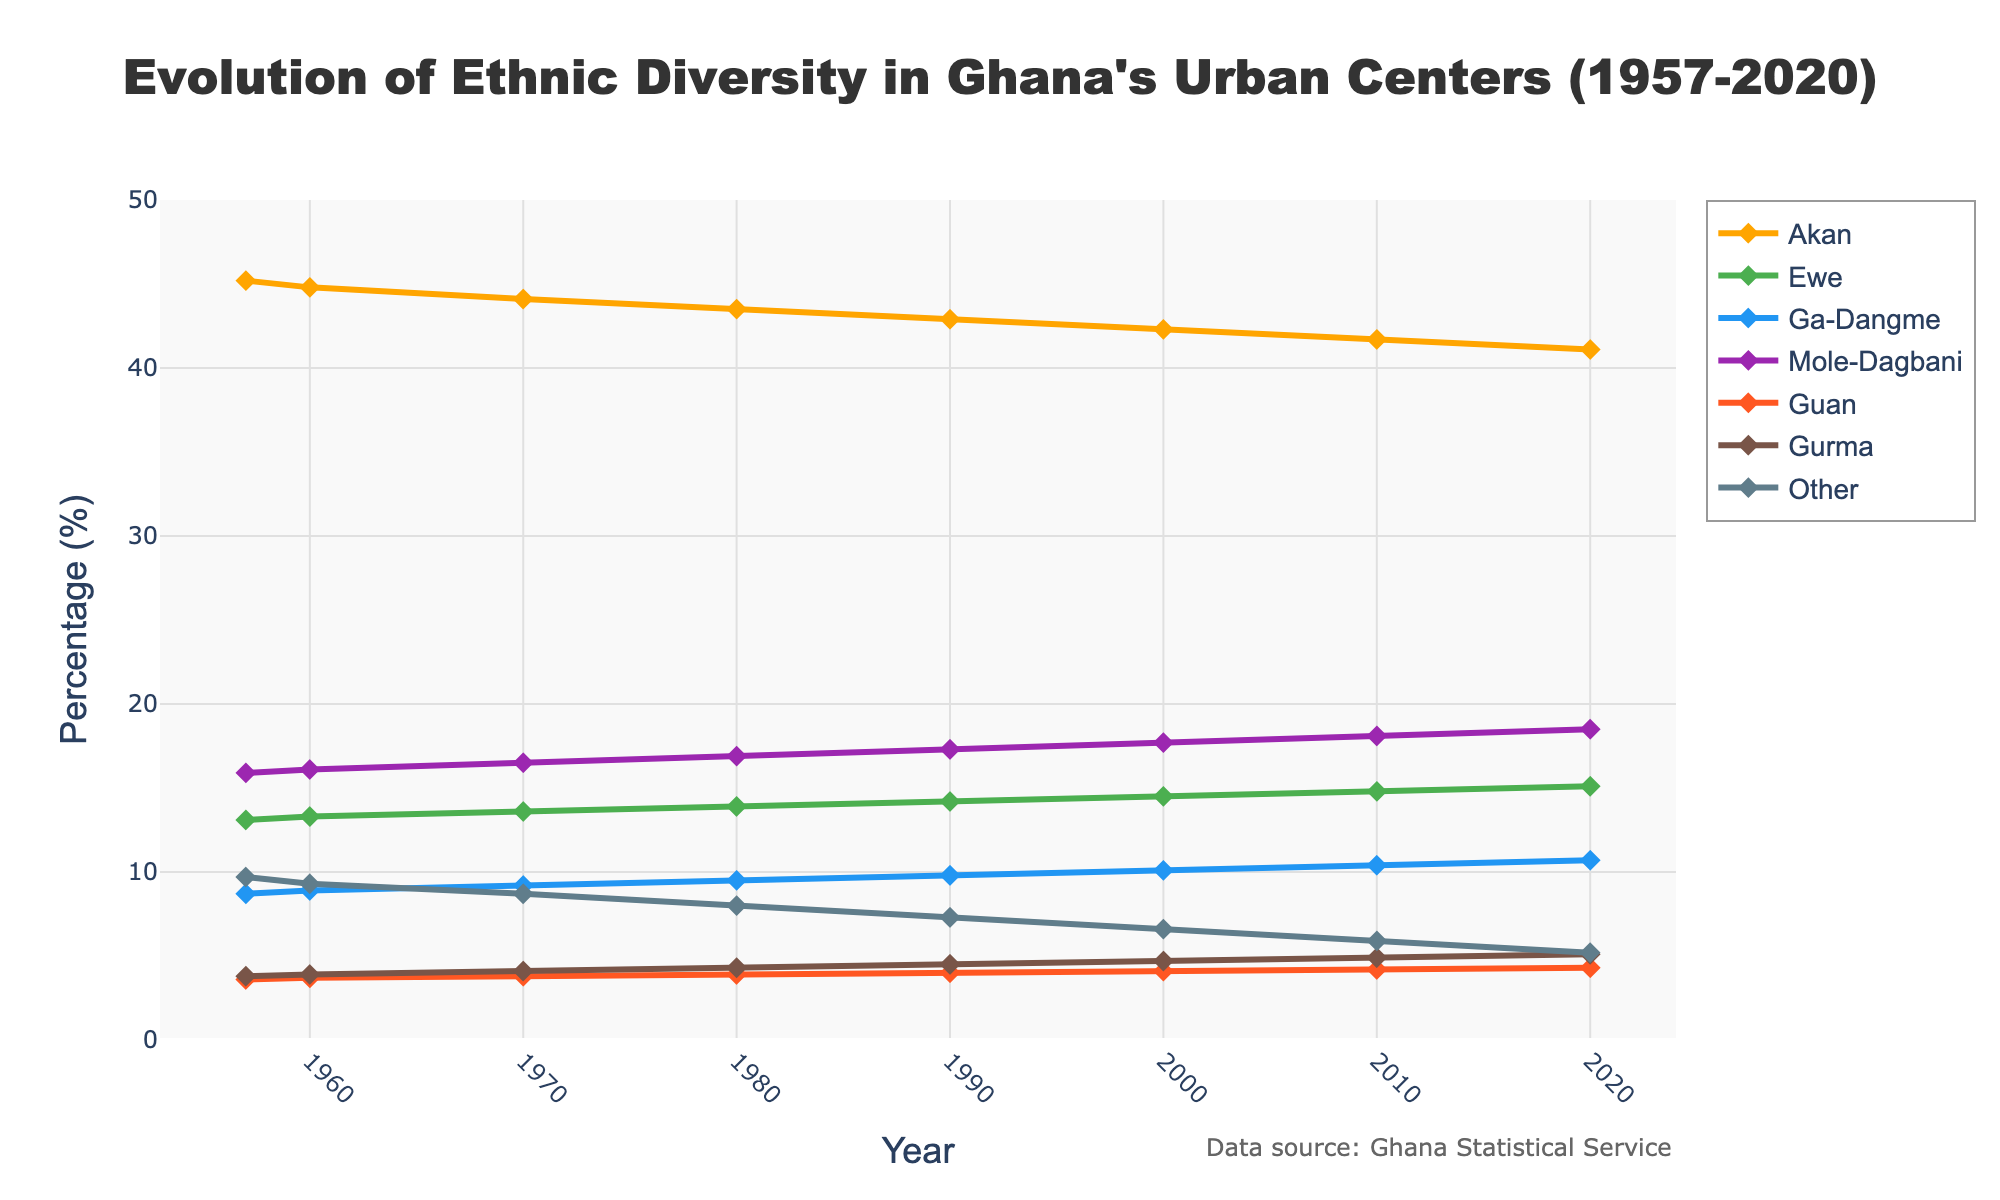What was the percentage of the Akan ethnic group in 1957 compared to 2020? The percentage of the Akan ethnic group in 1957 was 45.2%, and in 2020, it was 41.1%. Thus, the percentage of the Akan ethnic group decreased by 45.2% - 41.1% = 4.1% over the given period.
Answer: 4.1% Which ethnic group showed the most significant increase in percentage from 1957 to 2020? By comparing the percentages for each ethnic group in 1957 and 2020, Mole-Dagbani increased from 15.9% to 18.5%, a rise of 2.6%. Ewe increased from 13.1% to 15.1%, a rise of 2%. The other ethnic groups show minor increases or decreases, making Mole-Dagbani the group with the most significant increase.
Answer: Mole-Dagbani In which year did the Ga-Dangme ethnic group's percentage surpass 10%? By examining the plot, the percentage for Ga-Dangme was 8.7% in 1957 and gradually increased to 10.4% by 2010. Thus, the first year it surpassed 10% is 2000.
Answer: 2000 Which year shows the highest percentage for the Mole-Dagbani ethnic group? From the plot, the percentage of the Mole-Dagbani ethnic group gradually increases from 15.9% in 1957 to 18.5% in 2020. The highest percentage shown is 18.5% in 2020.
Answer: 2020 What is the combined percentage of the Ewe and Guan ethnic groups in 1970? From the plot, the percentage for the Ewe ethnic group in 1970 is 13.6%, and for the Guan ethnic group, it is 3.8%. Thus, the combined percentage is 13.6% + 3.8% = 17.4%.
Answer: 17.4% Did the percentage of the Gurma ethnic group ever become constant over time? The plot shows a gradual increase in the percentage of the Gurma ethnic group from 3.8% in 1957 to 5.1% in 2020. There are no periods of constancy; hence, the percentage never stayed constant over time.
Answer: No How does the percentage of the 'Other' ethnic groups trend over time between 1957 and 2020? From the plot, the percentage of the 'Other' ethnic groups decreases from 9.7% in 1957 to 5.2% in 2020, indicating a decreasing trend over time.
Answer: Decreasing What is the difference in the percentages of the Mole-Dagbani and Akan ethnic groups in 2020? The percentage of the Mole-Dagbani ethnic group in 2020 is 18.5%, and the Akan ethnic group is 41.1%. The difference is 41.1% - 18.5% = 22.6%.
Answer: 22.6% Which ethnic group had the second highest percentage in 1960? By examining the plot, the Akan ethnic group had the highest percentage in 1960 at 44.8%, and the Mole-Dagbani ethnic group had the second highest percentage at 16.1%.
Answer: Mole-Dagbani How much did the percentage of the Gurma ethnic group change from 1980 to 2010? The percentage of the Gurma ethnic group was 4.3% in 1980 and increased to 4.9% in 2010. The change is 4.9% - 4.3% = 0.6%.
Answer: 0.6% 